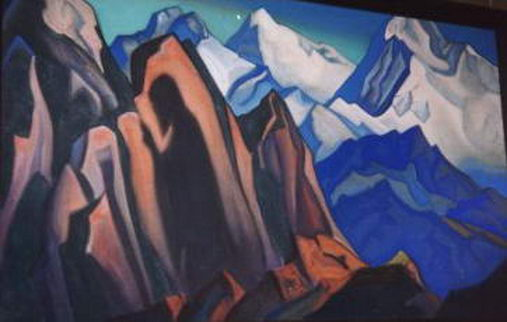If these mountains could tell a story, what narrative might they share with us? If these cubist-rendered mountains could tell a story, it would be a tale of timeless endurance and natural mastery. The mountains might recount their formation over eons, from the fiery birth in the belly of the earth, rising through immense pressure and force. They would share stories of ancient civilizations that revered them as sacred, drawing inspiration and spirituality from their looming presence. Tales of the wildlife that once roamed their slopes, the seasons passing in a rhythmic dance, would unfold. They would speak of climbers and adventurers who dared to scale their heights, each step a testament to human spirit and endurance. The narrative would be one of relationships—between rock and sky, earth and life, peace and challenge—embodying the perpetual cycle of nature's grandeur. What kind of mythical creature could inhabit such a landscape? In a landscape as striking and imaginative as this cubist mountain range, one might envision a mythical creature known as the 'Geomancer Dragon.' This dragon would not be of flesh and blood but made of the very elements that shape the mountains—its body formed from jagged rocks and crystalline structures, reflecting the geometric patterns of the cubist style. The Geomancer Dragon would have the ability to manipulate the landscape, causing the mountains to shift and change shape, creating new formations and hiding treasures within the earth. Its breath would be a cold, icy wind, reflecting the serene blues and purples of the landscape, and its eyes would glow with the warm oranges, casting a watchful gaze over its domain. This creature, embodying both the beauty and the harshness of the mountains, would be a guardian of the natural world, protecting the balance and harmony of the landscape. 